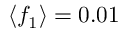Convert formula to latex. <formula><loc_0><loc_0><loc_500><loc_500>\langle f _ { 1 } \rangle = 0 . 0 1</formula> 